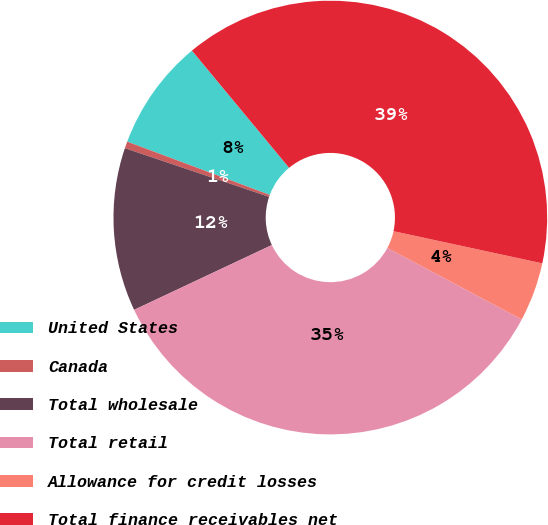Convert chart. <chart><loc_0><loc_0><loc_500><loc_500><pie_chart><fcel>United States<fcel>Canada<fcel>Total wholesale<fcel>Total retail<fcel>Allowance for credit losses<fcel>Total finance receivables net<nl><fcel>8.29%<fcel>0.51%<fcel>12.18%<fcel>35.21%<fcel>4.4%<fcel>39.4%<nl></chart> 